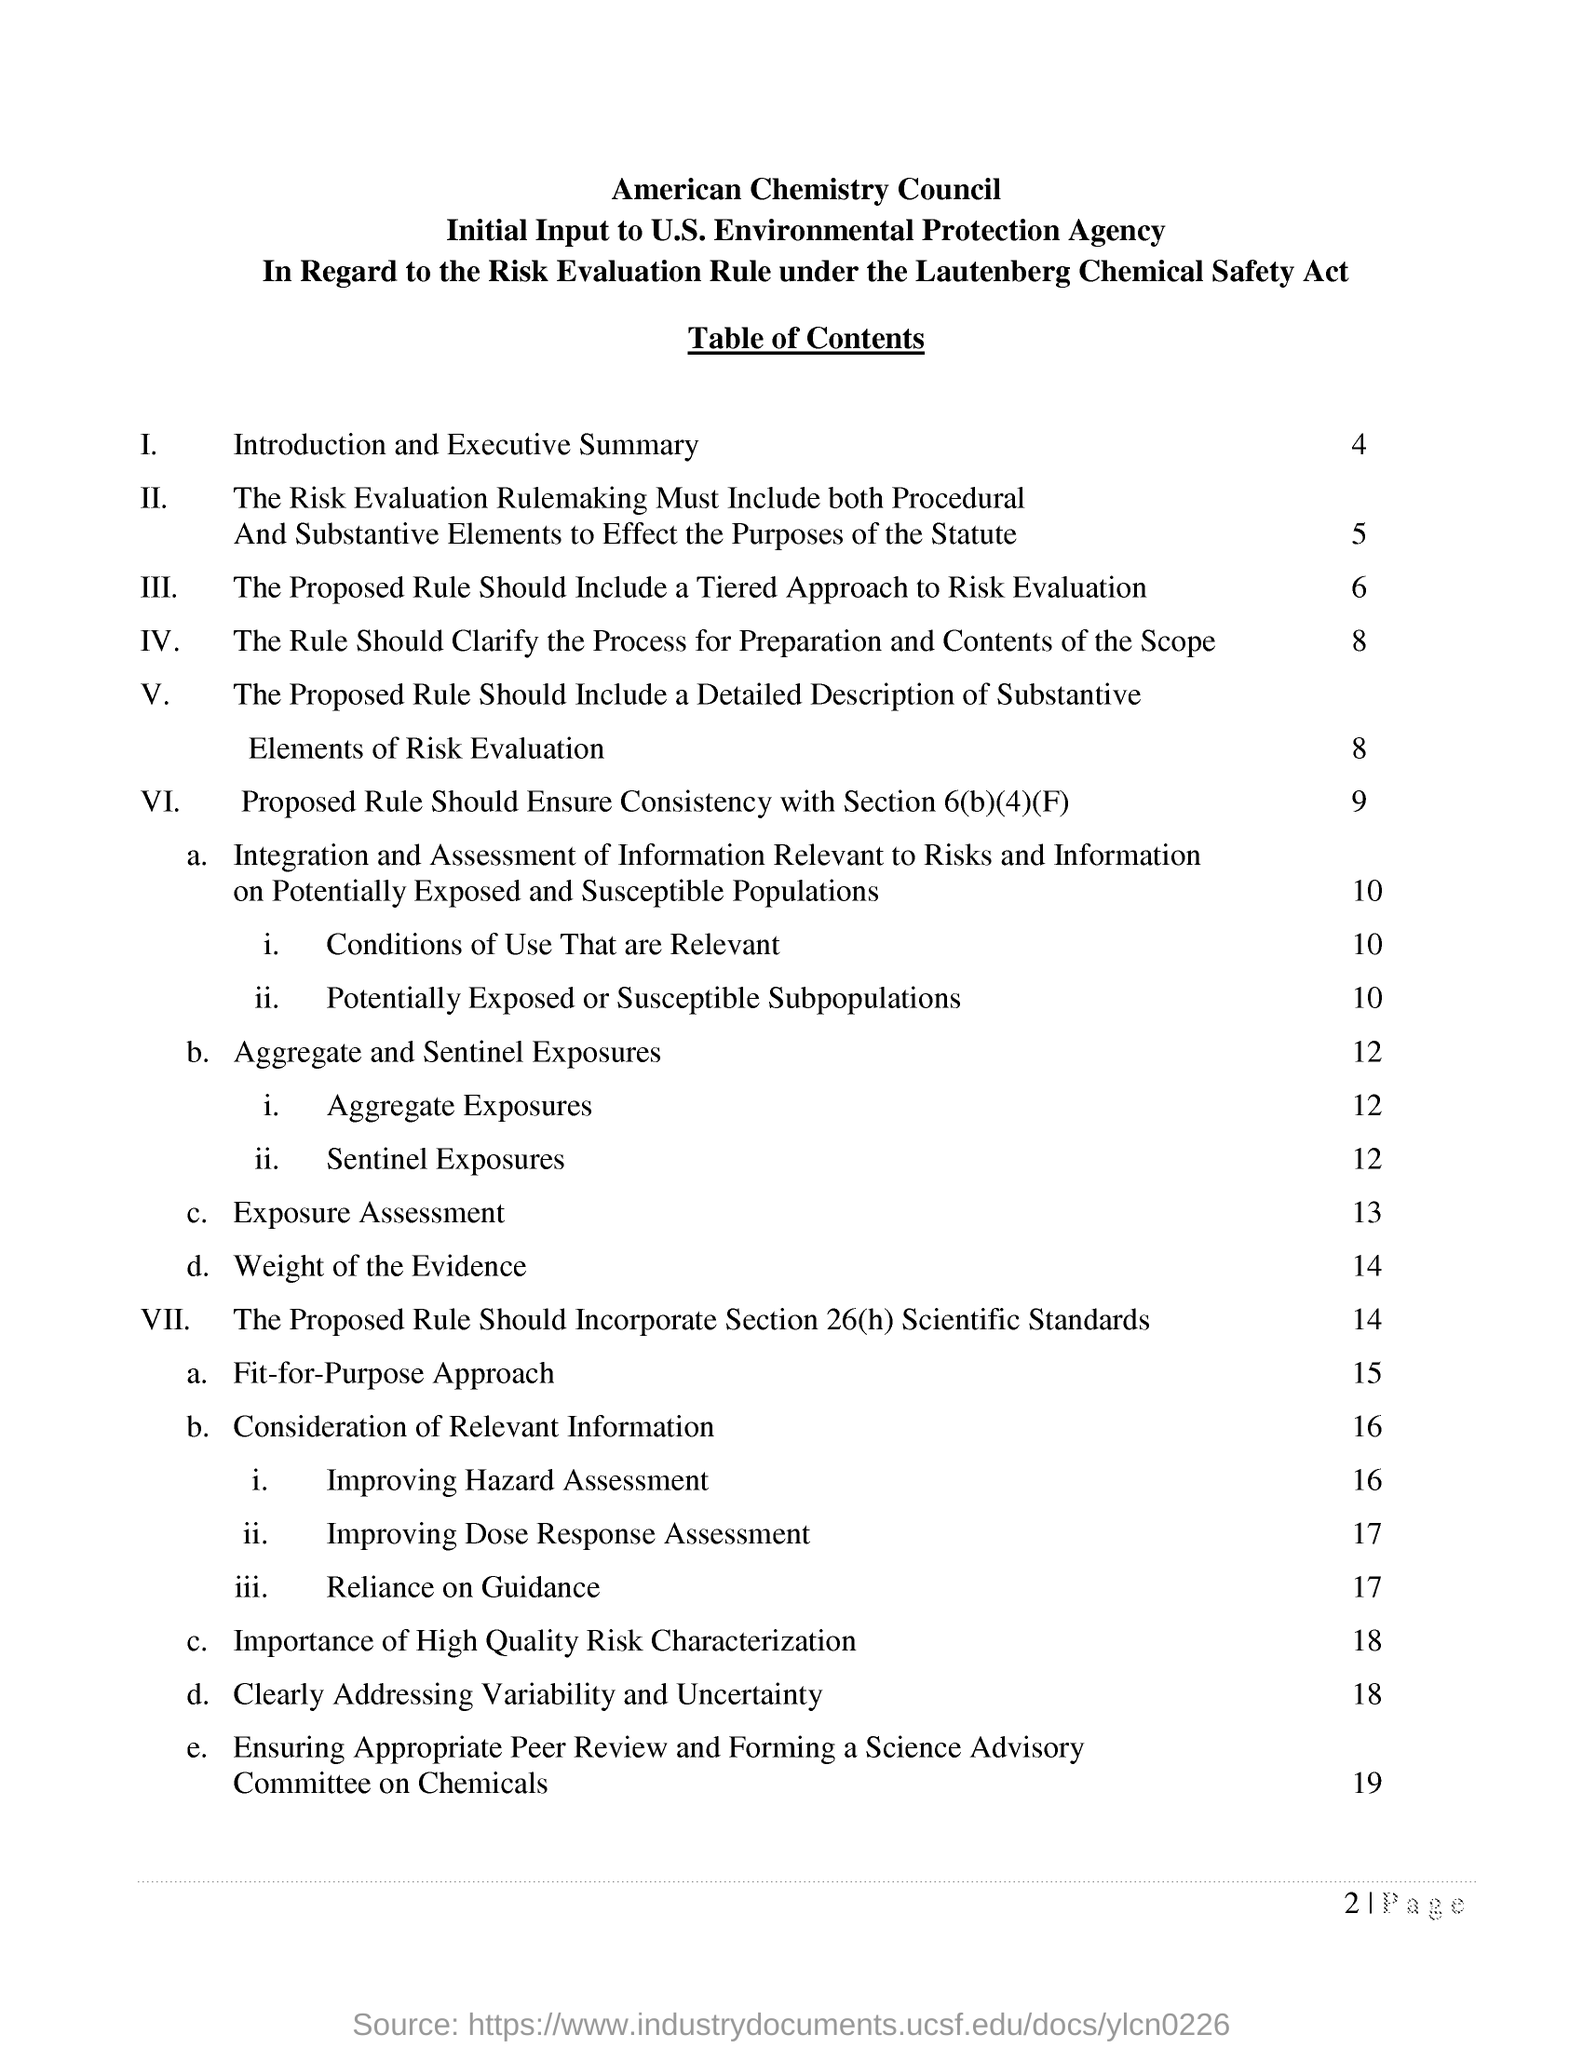Under which  safety act this is performed ?
Offer a terse response. Launtenberg Chemical Safety Act. Under which country  initial input to environmental protection agency is performed ?
Provide a succinct answer. U.S. What is mentioned in the table content 1 ?
Your answer should be very brief. Introduction and Executive Summary. 